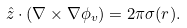Convert formula to latex. <formula><loc_0><loc_0><loc_500><loc_500>\hat { z } \cdot ( \nabla \times \nabla \phi _ { v } ) = 2 \pi \sigma ( r ) .</formula> 